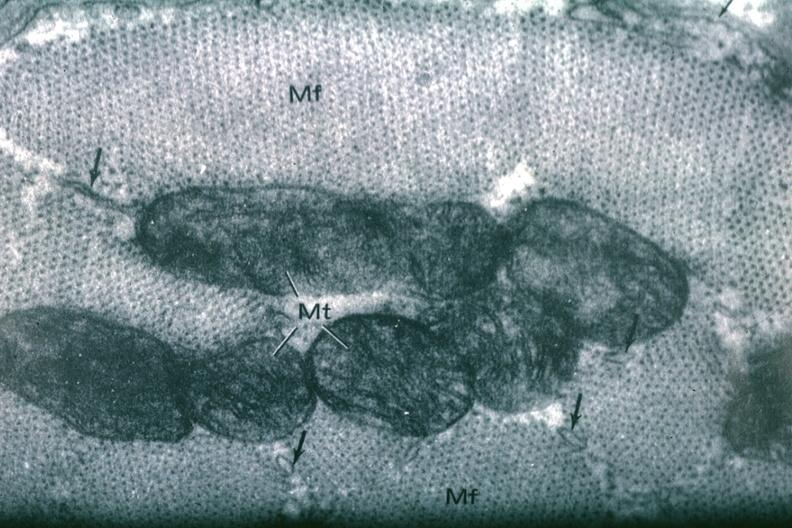what is present?
Answer the question using a single word or phrase. Cardiovascular 